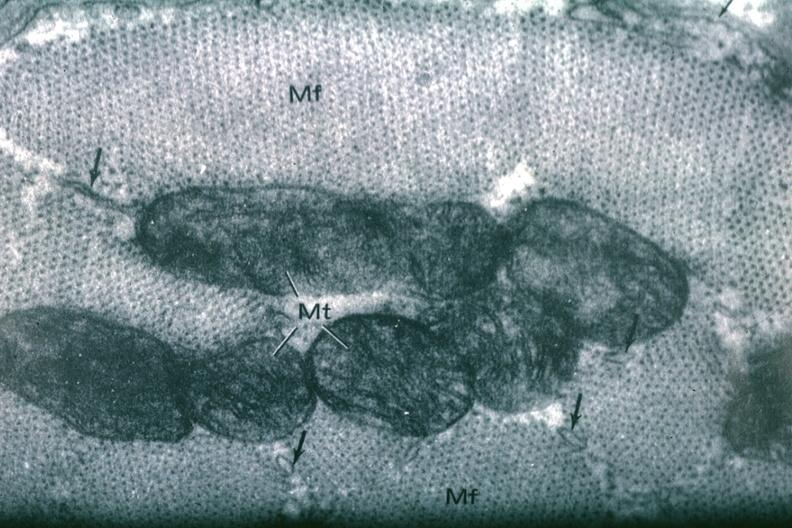what is present?
Answer the question using a single word or phrase. Cardiovascular 